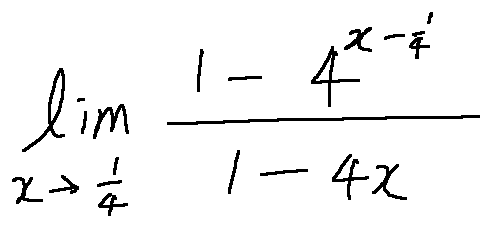<formula> <loc_0><loc_0><loc_500><loc_500>\lim \lim i t s _ { x \rightarrow \frac { 1 } { 4 } } \frac { 1 - 4 ^ { x - \frac { 1 } { 4 } } } { 1 - 4 x }</formula> 